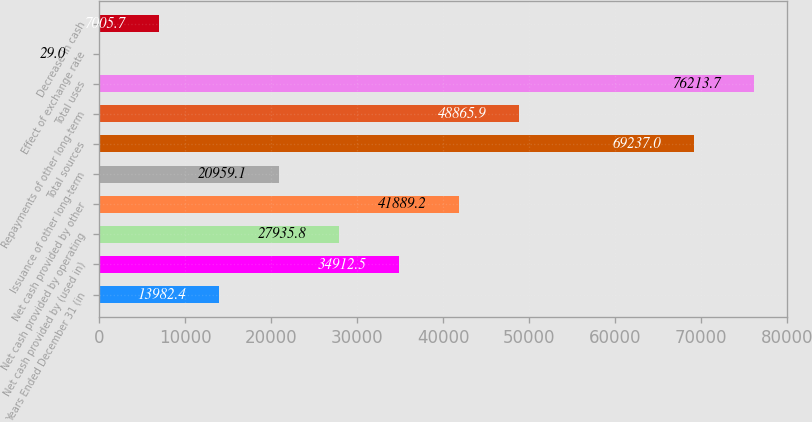Convert chart to OTSL. <chart><loc_0><loc_0><loc_500><loc_500><bar_chart><fcel>Years Ended December 31 (in<fcel>Net cash provided by (used in)<fcel>Net cash provided by operating<fcel>Net cash provided by other<fcel>Issuance of other long-term<fcel>Total sources<fcel>Repayments of other long-term<fcel>Total uses<fcel>Effect of exchange rate<fcel>Decrease in cash<nl><fcel>13982.4<fcel>34912.5<fcel>27935.8<fcel>41889.2<fcel>20959.1<fcel>69237<fcel>48865.9<fcel>76213.7<fcel>29<fcel>7005.7<nl></chart> 